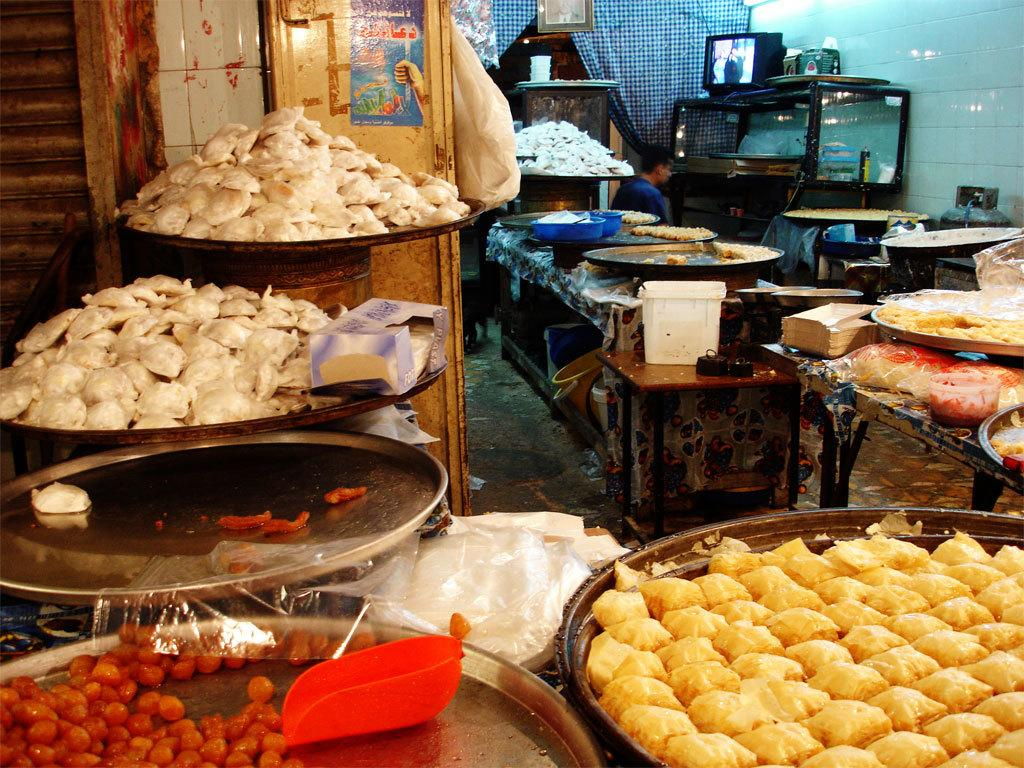What can be seen in the foreground of the image? There are food items on plates in the foreground of the image. What is located in the background of the image? There is a screen, a person, a rack, and other objects in the background of the image. Can you describe the screen in the background? Unfortunately, the facts provided do not give any details about the screen, so we cannot describe it further. How many geese are visible on the rack in the background of the image? There are no geese present in the image, and the rack does not have any geese on it. What type of sheep can be seen interacting with the food items on the plates in the foreground of the image? There are no sheep present in the image, and the food items on the plates are not interacting with any animals. 